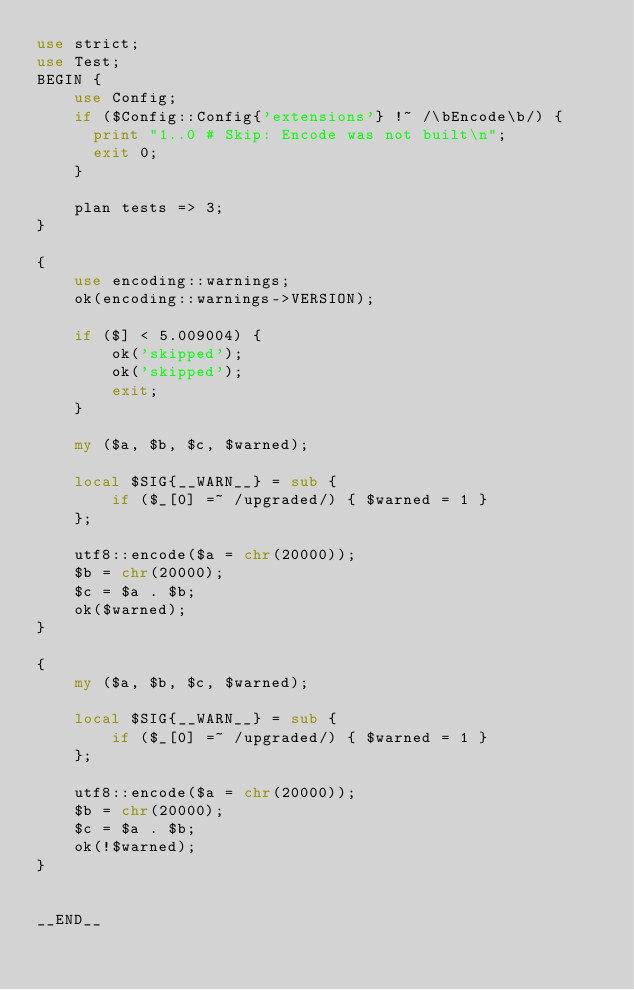Convert code to text. <code><loc_0><loc_0><loc_500><loc_500><_Perl_>use strict;
use Test;
BEGIN {
    use Config;
    if ($Config::Config{'extensions'} !~ /\bEncode\b/) {
      print "1..0 # Skip: Encode was not built\n";
      exit 0;
    }

    plan tests => 3;
}

{
    use encoding::warnings;
    ok(encoding::warnings->VERSION);

    if ($] < 5.009004) {
        ok('skipped');
        ok('skipped');
        exit;
    }

    my ($a, $b, $c, $warned);

    local $SIG{__WARN__} = sub {
        if ($_[0] =~ /upgraded/) { $warned = 1 }
    };

    utf8::encode($a = chr(20000));
    $b = chr(20000);
    $c = $a . $b;
    ok($warned);
}

{
    my ($a, $b, $c, $warned);

    local $SIG{__WARN__} = sub {
        if ($_[0] =~ /upgraded/) { $warned = 1 }
    };

    utf8::encode($a = chr(20000));
    $b = chr(20000);
    $c = $a . $b;
    ok(!$warned);
}


__END__
</code> 